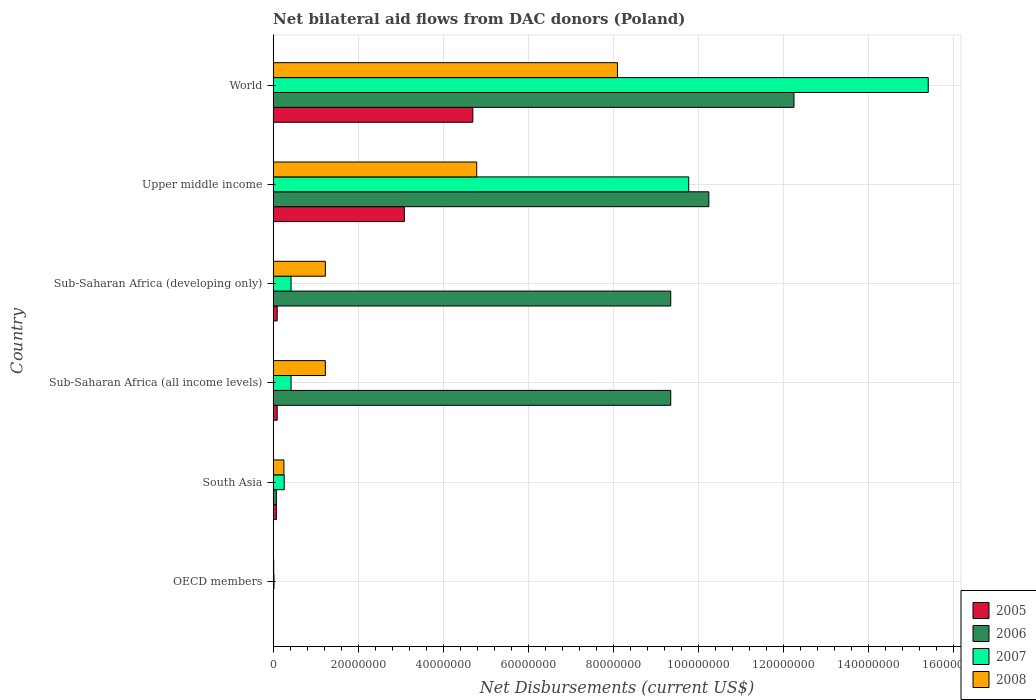Are the number of bars on each tick of the Y-axis equal?
Keep it short and to the point. Yes. What is the label of the 2nd group of bars from the top?
Give a very brief answer. Upper middle income. In how many cases, is the number of bars for a given country not equal to the number of legend labels?
Give a very brief answer. 0. What is the net bilateral aid flows in 2008 in Sub-Saharan Africa (all income levels)?
Provide a succinct answer. 1.23e+07. Across all countries, what is the maximum net bilateral aid flows in 2005?
Make the answer very short. 4.70e+07. What is the total net bilateral aid flows in 2005 in the graph?
Your answer should be compact. 8.06e+07. What is the difference between the net bilateral aid flows in 2005 in Sub-Saharan Africa (all income levels) and that in World?
Give a very brief answer. -4.60e+07. What is the difference between the net bilateral aid flows in 2006 in Sub-Saharan Africa (developing only) and the net bilateral aid flows in 2008 in Upper middle income?
Provide a short and direct response. 4.56e+07. What is the average net bilateral aid flows in 2005 per country?
Your response must be concise. 1.34e+07. What is the difference between the net bilateral aid flows in 2006 and net bilateral aid flows in 2007 in Sub-Saharan Africa (developing only)?
Keep it short and to the point. 8.93e+07. What is the ratio of the net bilateral aid flows in 2007 in OECD members to that in Upper middle income?
Offer a very short reply. 0. What is the difference between the highest and the second highest net bilateral aid flows in 2006?
Make the answer very short. 2.00e+07. What is the difference between the highest and the lowest net bilateral aid flows in 2005?
Offer a terse response. 4.69e+07. Is the sum of the net bilateral aid flows in 2006 in Sub-Saharan Africa (all income levels) and World greater than the maximum net bilateral aid flows in 2008 across all countries?
Your answer should be compact. Yes. Is it the case that in every country, the sum of the net bilateral aid flows in 2007 and net bilateral aid flows in 2008 is greater than the sum of net bilateral aid flows in 2006 and net bilateral aid flows in 2005?
Offer a terse response. No. What does the 4th bar from the top in Sub-Saharan Africa (all income levels) represents?
Your response must be concise. 2005. Is it the case that in every country, the sum of the net bilateral aid flows in 2006 and net bilateral aid flows in 2008 is greater than the net bilateral aid flows in 2007?
Your response must be concise. No. How many bars are there?
Provide a short and direct response. 24. Are all the bars in the graph horizontal?
Your answer should be compact. Yes. Does the graph contain any zero values?
Give a very brief answer. No. Does the graph contain grids?
Keep it short and to the point. Yes. How many legend labels are there?
Provide a short and direct response. 4. How are the legend labels stacked?
Your answer should be compact. Vertical. What is the title of the graph?
Your response must be concise. Net bilateral aid flows from DAC donors (Poland). Does "2005" appear as one of the legend labels in the graph?
Your response must be concise. Yes. What is the label or title of the X-axis?
Ensure brevity in your answer.  Net Disbursements (current US$). What is the Net Disbursements (current US$) of 2005 in OECD members?
Ensure brevity in your answer.  5.00e+04. What is the Net Disbursements (current US$) in 2006 in OECD members?
Offer a terse response. 3.00e+04. What is the Net Disbursements (current US$) in 2008 in OECD members?
Ensure brevity in your answer.  1.40e+05. What is the Net Disbursements (current US$) of 2005 in South Asia?
Your answer should be very brief. 7.70e+05. What is the Net Disbursements (current US$) of 2006 in South Asia?
Offer a very short reply. 7.70e+05. What is the Net Disbursements (current US$) of 2007 in South Asia?
Give a very brief answer. 2.61e+06. What is the Net Disbursements (current US$) of 2008 in South Asia?
Ensure brevity in your answer.  2.54e+06. What is the Net Disbursements (current US$) in 2005 in Sub-Saharan Africa (all income levels)?
Provide a succinct answer. 9.60e+05. What is the Net Disbursements (current US$) of 2006 in Sub-Saharan Africa (all income levels)?
Provide a short and direct response. 9.35e+07. What is the Net Disbursements (current US$) of 2007 in Sub-Saharan Africa (all income levels)?
Your answer should be compact. 4.22e+06. What is the Net Disbursements (current US$) in 2008 in Sub-Saharan Africa (all income levels)?
Give a very brief answer. 1.23e+07. What is the Net Disbursements (current US$) of 2005 in Sub-Saharan Africa (developing only)?
Keep it short and to the point. 9.60e+05. What is the Net Disbursements (current US$) in 2006 in Sub-Saharan Africa (developing only)?
Provide a succinct answer. 9.35e+07. What is the Net Disbursements (current US$) of 2007 in Sub-Saharan Africa (developing only)?
Make the answer very short. 4.22e+06. What is the Net Disbursements (current US$) in 2008 in Sub-Saharan Africa (developing only)?
Keep it short and to the point. 1.23e+07. What is the Net Disbursements (current US$) of 2005 in Upper middle income?
Your response must be concise. 3.09e+07. What is the Net Disbursements (current US$) in 2006 in Upper middle income?
Ensure brevity in your answer.  1.02e+08. What is the Net Disbursements (current US$) of 2007 in Upper middle income?
Your response must be concise. 9.78e+07. What is the Net Disbursements (current US$) of 2008 in Upper middle income?
Offer a very short reply. 4.79e+07. What is the Net Disbursements (current US$) in 2005 in World?
Provide a short and direct response. 4.70e+07. What is the Net Disbursements (current US$) in 2006 in World?
Offer a very short reply. 1.23e+08. What is the Net Disbursements (current US$) of 2007 in World?
Your answer should be compact. 1.54e+08. What is the Net Disbursements (current US$) in 2008 in World?
Offer a terse response. 8.10e+07. Across all countries, what is the maximum Net Disbursements (current US$) in 2005?
Your answer should be very brief. 4.70e+07. Across all countries, what is the maximum Net Disbursements (current US$) in 2006?
Offer a terse response. 1.23e+08. Across all countries, what is the maximum Net Disbursements (current US$) in 2007?
Give a very brief answer. 1.54e+08. Across all countries, what is the maximum Net Disbursements (current US$) in 2008?
Your response must be concise. 8.10e+07. Across all countries, what is the minimum Net Disbursements (current US$) of 2005?
Offer a terse response. 5.00e+04. Across all countries, what is the minimum Net Disbursements (current US$) of 2006?
Provide a short and direct response. 3.00e+04. Across all countries, what is the minimum Net Disbursements (current US$) of 2007?
Give a very brief answer. 2.10e+05. Across all countries, what is the minimum Net Disbursements (current US$) in 2008?
Ensure brevity in your answer.  1.40e+05. What is the total Net Disbursements (current US$) in 2005 in the graph?
Offer a terse response. 8.06e+07. What is the total Net Disbursements (current US$) in 2006 in the graph?
Offer a terse response. 4.13e+08. What is the total Net Disbursements (current US$) in 2007 in the graph?
Your answer should be very brief. 2.63e+08. What is the total Net Disbursements (current US$) in 2008 in the graph?
Ensure brevity in your answer.  1.56e+08. What is the difference between the Net Disbursements (current US$) in 2005 in OECD members and that in South Asia?
Offer a very short reply. -7.20e+05. What is the difference between the Net Disbursements (current US$) of 2006 in OECD members and that in South Asia?
Make the answer very short. -7.40e+05. What is the difference between the Net Disbursements (current US$) in 2007 in OECD members and that in South Asia?
Give a very brief answer. -2.40e+06. What is the difference between the Net Disbursements (current US$) in 2008 in OECD members and that in South Asia?
Provide a short and direct response. -2.40e+06. What is the difference between the Net Disbursements (current US$) of 2005 in OECD members and that in Sub-Saharan Africa (all income levels)?
Make the answer very short. -9.10e+05. What is the difference between the Net Disbursements (current US$) in 2006 in OECD members and that in Sub-Saharan Africa (all income levels)?
Make the answer very short. -9.35e+07. What is the difference between the Net Disbursements (current US$) of 2007 in OECD members and that in Sub-Saharan Africa (all income levels)?
Keep it short and to the point. -4.01e+06. What is the difference between the Net Disbursements (current US$) of 2008 in OECD members and that in Sub-Saharan Africa (all income levels)?
Offer a very short reply. -1.22e+07. What is the difference between the Net Disbursements (current US$) in 2005 in OECD members and that in Sub-Saharan Africa (developing only)?
Give a very brief answer. -9.10e+05. What is the difference between the Net Disbursements (current US$) in 2006 in OECD members and that in Sub-Saharan Africa (developing only)?
Make the answer very short. -9.35e+07. What is the difference between the Net Disbursements (current US$) of 2007 in OECD members and that in Sub-Saharan Africa (developing only)?
Provide a succinct answer. -4.01e+06. What is the difference between the Net Disbursements (current US$) in 2008 in OECD members and that in Sub-Saharan Africa (developing only)?
Give a very brief answer. -1.22e+07. What is the difference between the Net Disbursements (current US$) of 2005 in OECD members and that in Upper middle income?
Your response must be concise. -3.08e+07. What is the difference between the Net Disbursements (current US$) in 2006 in OECD members and that in Upper middle income?
Offer a terse response. -1.02e+08. What is the difference between the Net Disbursements (current US$) in 2007 in OECD members and that in Upper middle income?
Your response must be concise. -9.76e+07. What is the difference between the Net Disbursements (current US$) of 2008 in OECD members and that in Upper middle income?
Keep it short and to the point. -4.78e+07. What is the difference between the Net Disbursements (current US$) of 2005 in OECD members and that in World?
Ensure brevity in your answer.  -4.69e+07. What is the difference between the Net Disbursements (current US$) in 2006 in OECD members and that in World?
Keep it short and to the point. -1.22e+08. What is the difference between the Net Disbursements (current US$) in 2007 in OECD members and that in World?
Your answer should be compact. -1.54e+08. What is the difference between the Net Disbursements (current US$) of 2008 in OECD members and that in World?
Ensure brevity in your answer.  -8.09e+07. What is the difference between the Net Disbursements (current US$) of 2006 in South Asia and that in Sub-Saharan Africa (all income levels)?
Your answer should be very brief. -9.28e+07. What is the difference between the Net Disbursements (current US$) of 2007 in South Asia and that in Sub-Saharan Africa (all income levels)?
Your answer should be very brief. -1.61e+06. What is the difference between the Net Disbursements (current US$) of 2008 in South Asia and that in Sub-Saharan Africa (all income levels)?
Give a very brief answer. -9.75e+06. What is the difference between the Net Disbursements (current US$) of 2006 in South Asia and that in Sub-Saharan Africa (developing only)?
Your answer should be compact. -9.28e+07. What is the difference between the Net Disbursements (current US$) in 2007 in South Asia and that in Sub-Saharan Africa (developing only)?
Ensure brevity in your answer.  -1.61e+06. What is the difference between the Net Disbursements (current US$) of 2008 in South Asia and that in Sub-Saharan Africa (developing only)?
Offer a terse response. -9.75e+06. What is the difference between the Net Disbursements (current US$) in 2005 in South Asia and that in Upper middle income?
Provide a succinct answer. -3.01e+07. What is the difference between the Net Disbursements (current US$) in 2006 in South Asia and that in Upper middle income?
Keep it short and to the point. -1.02e+08. What is the difference between the Net Disbursements (current US$) of 2007 in South Asia and that in Upper middle income?
Your answer should be very brief. -9.52e+07. What is the difference between the Net Disbursements (current US$) in 2008 in South Asia and that in Upper middle income?
Ensure brevity in your answer.  -4.54e+07. What is the difference between the Net Disbursements (current US$) in 2005 in South Asia and that in World?
Provide a succinct answer. -4.62e+07. What is the difference between the Net Disbursements (current US$) of 2006 in South Asia and that in World?
Ensure brevity in your answer.  -1.22e+08. What is the difference between the Net Disbursements (current US$) in 2007 in South Asia and that in World?
Offer a very short reply. -1.52e+08. What is the difference between the Net Disbursements (current US$) in 2008 in South Asia and that in World?
Provide a succinct answer. -7.85e+07. What is the difference between the Net Disbursements (current US$) in 2006 in Sub-Saharan Africa (all income levels) and that in Sub-Saharan Africa (developing only)?
Offer a very short reply. 0. What is the difference between the Net Disbursements (current US$) in 2005 in Sub-Saharan Africa (all income levels) and that in Upper middle income?
Keep it short and to the point. -2.99e+07. What is the difference between the Net Disbursements (current US$) in 2006 in Sub-Saharan Africa (all income levels) and that in Upper middle income?
Your answer should be compact. -8.96e+06. What is the difference between the Net Disbursements (current US$) in 2007 in Sub-Saharan Africa (all income levels) and that in Upper middle income?
Offer a terse response. -9.36e+07. What is the difference between the Net Disbursements (current US$) of 2008 in Sub-Saharan Africa (all income levels) and that in Upper middle income?
Offer a very short reply. -3.56e+07. What is the difference between the Net Disbursements (current US$) in 2005 in Sub-Saharan Africa (all income levels) and that in World?
Give a very brief answer. -4.60e+07. What is the difference between the Net Disbursements (current US$) in 2006 in Sub-Saharan Africa (all income levels) and that in World?
Your answer should be very brief. -2.90e+07. What is the difference between the Net Disbursements (current US$) of 2007 in Sub-Saharan Africa (all income levels) and that in World?
Make the answer very short. -1.50e+08. What is the difference between the Net Disbursements (current US$) of 2008 in Sub-Saharan Africa (all income levels) and that in World?
Make the answer very short. -6.87e+07. What is the difference between the Net Disbursements (current US$) of 2005 in Sub-Saharan Africa (developing only) and that in Upper middle income?
Give a very brief answer. -2.99e+07. What is the difference between the Net Disbursements (current US$) of 2006 in Sub-Saharan Africa (developing only) and that in Upper middle income?
Provide a short and direct response. -8.96e+06. What is the difference between the Net Disbursements (current US$) of 2007 in Sub-Saharan Africa (developing only) and that in Upper middle income?
Keep it short and to the point. -9.36e+07. What is the difference between the Net Disbursements (current US$) of 2008 in Sub-Saharan Africa (developing only) and that in Upper middle income?
Ensure brevity in your answer.  -3.56e+07. What is the difference between the Net Disbursements (current US$) in 2005 in Sub-Saharan Africa (developing only) and that in World?
Your response must be concise. -4.60e+07. What is the difference between the Net Disbursements (current US$) in 2006 in Sub-Saharan Africa (developing only) and that in World?
Provide a short and direct response. -2.90e+07. What is the difference between the Net Disbursements (current US$) in 2007 in Sub-Saharan Africa (developing only) and that in World?
Provide a succinct answer. -1.50e+08. What is the difference between the Net Disbursements (current US$) of 2008 in Sub-Saharan Africa (developing only) and that in World?
Offer a very short reply. -6.87e+07. What is the difference between the Net Disbursements (current US$) in 2005 in Upper middle income and that in World?
Your answer should be very brief. -1.61e+07. What is the difference between the Net Disbursements (current US$) in 2006 in Upper middle income and that in World?
Provide a succinct answer. -2.00e+07. What is the difference between the Net Disbursements (current US$) of 2007 in Upper middle income and that in World?
Provide a short and direct response. -5.63e+07. What is the difference between the Net Disbursements (current US$) of 2008 in Upper middle income and that in World?
Provide a short and direct response. -3.31e+07. What is the difference between the Net Disbursements (current US$) in 2005 in OECD members and the Net Disbursements (current US$) in 2006 in South Asia?
Offer a very short reply. -7.20e+05. What is the difference between the Net Disbursements (current US$) in 2005 in OECD members and the Net Disbursements (current US$) in 2007 in South Asia?
Provide a short and direct response. -2.56e+06. What is the difference between the Net Disbursements (current US$) of 2005 in OECD members and the Net Disbursements (current US$) of 2008 in South Asia?
Provide a short and direct response. -2.49e+06. What is the difference between the Net Disbursements (current US$) of 2006 in OECD members and the Net Disbursements (current US$) of 2007 in South Asia?
Offer a terse response. -2.58e+06. What is the difference between the Net Disbursements (current US$) in 2006 in OECD members and the Net Disbursements (current US$) in 2008 in South Asia?
Give a very brief answer. -2.51e+06. What is the difference between the Net Disbursements (current US$) in 2007 in OECD members and the Net Disbursements (current US$) in 2008 in South Asia?
Your answer should be compact. -2.33e+06. What is the difference between the Net Disbursements (current US$) of 2005 in OECD members and the Net Disbursements (current US$) of 2006 in Sub-Saharan Africa (all income levels)?
Your response must be concise. -9.35e+07. What is the difference between the Net Disbursements (current US$) of 2005 in OECD members and the Net Disbursements (current US$) of 2007 in Sub-Saharan Africa (all income levels)?
Keep it short and to the point. -4.17e+06. What is the difference between the Net Disbursements (current US$) in 2005 in OECD members and the Net Disbursements (current US$) in 2008 in Sub-Saharan Africa (all income levels)?
Give a very brief answer. -1.22e+07. What is the difference between the Net Disbursements (current US$) of 2006 in OECD members and the Net Disbursements (current US$) of 2007 in Sub-Saharan Africa (all income levels)?
Your response must be concise. -4.19e+06. What is the difference between the Net Disbursements (current US$) of 2006 in OECD members and the Net Disbursements (current US$) of 2008 in Sub-Saharan Africa (all income levels)?
Provide a short and direct response. -1.23e+07. What is the difference between the Net Disbursements (current US$) in 2007 in OECD members and the Net Disbursements (current US$) in 2008 in Sub-Saharan Africa (all income levels)?
Your answer should be very brief. -1.21e+07. What is the difference between the Net Disbursements (current US$) in 2005 in OECD members and the Net Disbursements (current US$) in 2006 in Sub-Saharan Africa (developing only)?
Make the answer very short. -9.35e+07. What is the difference between the Net Disbursements (current US$) of 2005 in OECD members and the Net Disbursements (current US$) of 2007 in Sub-Saharan Africa (developing only)?
Your answer should be very brief. -4.17e+06. What is the difference between the Net Disbursements (current US$) of 2005 in OECD members and the Net Disbursements (current US$) of 2008 in Sub-Saharan Africa (developing only)?
Offer a terse response. -1.22e+07. What is the difference between the Net Disbursements (current US$) in 2006 in OECD members and the Net Disbursements (current US$) in 2007 in Sub-Saharan Africa (developing only)?
Offer a terse response. -4.19e+06. What is the difference between the Net Disbursements (current US$) of 2006 in OECD members and the Net Disbursements (current US$) of 2008 in Sub-Saharan Africa (developing only)?
Give a very brief answer. -1.23e+07. What is the difference between the Net Disbursements (current US$) in 2007 in OECD members and the Net Disbursements (current US$) in 2008 in Sub-Saharan Africa (developing only)?
Give a very brief answer. -1.21e+07. What is the difference between the Net Disbursements (current US$) of 2005 in OECD members and the Net Disbursements (current US$) of 2006 in Upper middle income?
Keep it short and to the point. -1.02e+08. What is the difference between the Net Disbursements (current US$) in 2005 in OECD members and the Net Disbursements (current US$) in 2007 in Upper middle income?
Give a very brief answer. -9.77e+07. What is the difference between the Net Disbursements (current US$) in 2005 in OECD members and the Net Disbursements (current US$) in 2008 in Upper middle income?
Your response must be concise. -4.78e+07. What is the difference between the Net Disbursements (current US$) of 2006 in OECD members and the Net Disbursements (current US$) of 2007 in Upper middle income?
Provide a succinct answer. -9.77e+07. What is the difference between the Net Disbursements (current US$) in 2006 in OECD members and the Net Disbursements (current US$) in 2008 in Upper middle income?
Provide a short and direct response. -4.79e+07. What is the difference between the Net Disbursements (current US$) in 2007 in OECD members and the Net Disbursements (current US$) in 2008 in Upper middle income?
Give a very brief answer. -4.77e+07. What is the difference between the Net Disbursements (current US$) in 2005 in OECD members and the Net Disbursements (current US$) in 2006 in World?
Your answer should be compact. -1.22e+08. What is the difference between the Net Disbursements (current US$) in 2005 in OECD members and the Net Disbursements (current US$) in 2007 in World?
Your answer should be compact. -1.54e+08. What is the difference between the Net Disbursements (current US$) of 2005 in OECD members and the Net Disbursements (current US$) of 2008 in World?
Your answer should be compact. -8.10e+07. What is the difference between the Net Disbursements (current US$) of 2006 in OECD members and the Net Disbursements (current US$) of 2007 in World?
Offer a terse response. -1.54e+08. What is the difference between the Net Disbursements (current US$) of 2006 in OECD members and the Net Disbursements (current US$) of 2008 in World?
Keep it short and to the point. -8.10e+07. What is the difference between the Net Disbursements (current US$) of 2007 in OECD members and the Net Disbursements (current US$) of 2008 in World?
Ensure brevity in your answer.  -8.08e+07. What is the difference between the Net Disbursements (current US$) in 2005 in South Asia and the Net Disbursements (current US$) in 2006 in Sub-Saharan Africa (all income levels)?
Give a very brief answer. -9.28e+07. What is the difference between the Net Disbursements (current US$) in 2005 in South Asia and the Net Disbursements (current US$) in 2007 in Sub-Saharan Africa (all income levels)?
Give a very brief answer. -3.45e+06. What is the difference between the Net Disbursements (current US$) in 2005 in South Asia and the Net Disbursements (current US$) in 2008 in Sub-Saharan Africa (all income levels)?
Your answer should be very brief. -1.15e+07. What is the difference between the Net Disbursements (current US$) in 2006 in South Asia and the Net Disbursements (current US$) in 2007 in Sub-Saharan Africa (all income levels)?
Offer a terse response. -3.45e+06. What is the difference between the Net Disbursements (current US$) in 2006 in South Asia and the Net Disbursements (current US$) in 2008 in Sub-Saharan Africa (all income levels)?
Make the answer very short. -1.15e+07. What is the difference between the Net Disbursements (current US$) in 2007 in South Asia and the Net Disbursements (current US$) in 2008 in Sub-Saharan Africa (all income levels)?
Your response must be concise. -9.68e+06. What is the difference between the Net Disbursements (current US$) of 2005 in South Asia and the Net Disbursements (current US$) of 2006 in Sub-Saharan Africa (developing only)?
Keep it short and to the point. -9.28e+07. What is the difference between the Net Disbursements (current US$) of 2005 in South Asia and the Net Disbursements (current US$) of 2007 in Sub-Saharan Africa (developing only)?
Your answer should be compact. -3.45e+06. What is the difference between the Net Disbursements (current US$) of 2005 in South Asia and the Net Disbursements (current US$) of 2008 in Sub-Saharan Africa (developing only)?
Make the answer very short. -1.15e+07. What is the difference between the Net Disbursements (current US$) of 2006 in South Asia and the Net Disbursements (current US$) of 2007 in Sub-Saharan Africa (developing only)?
Offer a terse response. -3.45e+06. What is the difference between the Net Disbursements (current US$) in 2006 in South Asia and the Net Disbursements (current US$) in 2008 in Sub-Saharan Africa (developing only)?
Your answer should be compact. -1.15e+07. What is the difference between the Net Disbursements (current US$) of 2007 in South Asia and the Net Disbursements (current US$) of 2008 in Sub-Saharan Africa (developing only)?
Ensure brevity in your answer.  -9.68e+06. What is the difference between the Net Disbursements (current US$) of 2005 in South Asia and the Net Disbursements (current US$) of 2006 in Upper middle income?
Your response must be concise. -1.02e+08. What is the difference between the Net Disbursements (current US$) of 2005 in South Asia and the Net Disbursements (current US$) of 2007 in Upper middle income?
Offer a very short reply. -9.70e+07. What is the difference between the Net Disbursements (current US$) in 2005 in South Asia and the Net Disbursements (current US$) in 2008 in Upper middle income?
Provide a short and direct response. -4.71e+07. What is the difference between the Net Disbursements (current US$) in 2006 in South Asia and the Net Disbursements (current US$) in 2007 in Upper middle income?
Your answer should be compact. -9.70e+07. What is the difference between the Net Disbursements (current US$) in 2006 in South Asia and the Net Disbursements (current US$) in 2008 in Upper middle income?
Offer a very short reply. -4.71e+07. What is the difference between the Net Disbursements (current US$) in 2007 in South Asia and the Net Disbursements (current US$) in 2008 in Upper middle income?
Provide a short and direct response. -4.53e+07. What is the difference between the Net Disbursements (current US$) in 2005 in South Asia and the Net Disbursements (current US$) in 2006 in World?
Keep it short and to the point. -1.22e+08. What is the difference between the Net Disbursements (current US$) in 2005 in South Asia and the Net Disbursements (current US$) in 2007 in World?
Your response must be concise. -1.53e+08. What is the difference between the Net Disbursements (current US$) of 2005 in South Asia and the Net Disbursements (current US$) of 2008 in World?
Offer a terse response. -8.02e+07. What is the difference between the Net Disbursements (current US$) of 2006 in South Asia and the Net Disbursements (current US$) of 2007 in World?
Your answer should be compact. -1.53e+08. What is the difference between the Net Disbursements (current US$) of 2006 in South Asia and the Net Disbursements (current US$) of 2008 in World?
Offer a very short reply. -8.02e+07. What is the difference between the Net Disbursements (current US$) in 2007 in South Asia and the Net Disbursements (current US$) in 2008 in World?
Provide a short and direct response. -7.84e+07. What is the difference between the Net Disbursements (current US$) of 2005 in Sub-Saharan Africa (all income levels) and the Net Disbursements (current US$) of 2006 in Sub-Saharan Africa (developing only)?
Provide a succinct answer. -9.26e+07. What is the difference between the Net Disbursements (current US$) in 2005 in Sub-Saharan Africa (all income levels) and the Net Disbursements (current US$) in 2007 in Sub-Saharan Africa (developing only)?
Offer a very short reply. -3.26e+06. What is the difference between the Net Disbursements (current US$) in 2005 in Sub-Saharan Africa (all income levels) and the Net Disbursements (current US$) in 2008 in Sub-Saharan Africa (developing only)?
Your answer should be compact. -1.13e+07. What is the difference between the Net Disbursements (current US$) of 2006 in Sub-Saharan Africa (all income levels) and the Net Disbursements (current US$) of 2007 in Sub-Saharan Africa (developing only)?
Provide a succinct answer. 8.93e+07. What is the difference between the Net Disbursements (current US$) of 2006 in Sub-Saharan Africa (all income levels) and the Net Disbursements (current US$) of 2008 in Sub-Saharan Africa (developing only)?
Keep it short and to the point. 8.12e+07. What is the difference between the Net Disbursements (current US$) in 2007 in Sub-Saharan Africa (all income levels) and the Net Disbursements (current US$) in 2008 in Sub-Saharan Africa (developing only)?
Ensure brevity in your answer.  -8.07e+06. What is the difference between the Net Disbursements (current US$) in 2005 in Sub-Saharan Africa (all income levels) and the Net Disbursements (current US$) in 2006 in Upper middle income?
Provide a succinct answer. -1.02e+08. What is the difference between the Net Disbursements (current US$) of 2005 in Sub-Saharan Africa (all income levels) and the Net Disbursements (current US$) of 2007 in Upper middle income?
Your answer should be very brief. -9.68e+07. What is the difference between the Net Disbursements (current US$) in 2005 in Sub-Saharan Africa (all income levels) and the Net Disbursements (current US$) in 2008 in Upper middle income?
Make the answer very short. -4.69e+07. What is the difference between the Net Disbursements (current US$) in 2006 in Sub-Saharan Africa (all income levels) and the Net Disbursements (current US$) in 2007 in Upper middle income?
Your response must be concise. -4.23e+06. What is the difference between the Net Disbursements (current US$) in 2006 in Sub-Saharan Africa (all income levels) and the Net Disbursements (current US$) in 2008 in Upper middle income?
Offer a terse response. 4.56e+07. What is the difference between the Net Disbursements (current US$) of 2007 in Sub-Saharan Africa (all income levels) and the Net Disbursements (current US$) of 2008 in Upper middle income?
Make the answer very short. -4.37e+07. What is the difference between the Net Disbursements (current US$) of 2005 in Sub-Saharan Africa (all income levels) and the Net Disbursements (current US$) of 2006 in World?
Provide a succinct answer. -1.22e+08. What is the difference between the Net Disbursements (current US$) of 2005 in Sub-Saharan Africa (all income levels) and the Net Disbursements (current US$) of 2007 in World?
Your response must be concise. -1.53e+08. What is the difference between the Net Disbursements (current US$) of 2005 in Sub-Saharan Africa (all income levels) and the Net Disbursements (current US$) of 2008 in World?
Your answer should be compact. -8.00e+07. What is the difference between the Net Disbursements (current US$) in 2006 in Sub-Saharan Africa (all income levels) and the Net Disbursements (current US$) in 2007 in World?
Provide a succinct answer. -6.06e+07. What is the difference between the Net Disbursements (current US$) of 2006 in Sub-Saharan Africa (all income levels) and the Net Disbursements (current US$) of 2008 in World?
Offer a terse response. 1.25e+07. What is the difference between the Net Disbursements (current US$) in 2007 in Sub-Saharan Africa (all income levels) and the Net Disbursements (current US$) in 2008 in World?
Provide a short and direct response. -7.68e+07. What is the difference between the Net Disbursements (current US$) in 2005 in Sub-Saharan Africa (developing only) and the Net Disbursements (current US$) in 2006 in Upper middle income?
Your answer should be compact. -1.02e+08. What is the difference between the Net Disbursements (current US$) of 2005 in Sub-Saharan Africa (developing only) and the Net Disbursements (current US$) of 2007 in Upper middle income?
Keep it short and to the point. -9.68e+07. What is the difference between the Net Disbursements (current US$) of 2005 in Sub-Saharan Africa (developing only) and the Net Disbursements (current US$) of 2008 in Upper middle income?
Give a very brief answer. -4.69e+07. What is the difference between the Net Disbursements (current US$) in 2006 in Sub-Saharan Africa (developing only) and the Net Disbursements (current US$) in 2007 in Upper middle income?
Make the answer very short. -4.23e+06. What is the difference between the Net Disbursements (current US$) of 2006 in Sub-Saharan Africa (developing only) and the Net Disbursements (current US$) of 2008 in Upper middle income?
Make the answer very short. 4.56e+07. What is the difference between the Net Disbursements (current US$) of 2007 in Sub-Saharan Africa (developing only) and the Net Disbursements (current US$) of 2008 in Upper middle income?
Ensure brevity in your answer.  -4.37e+07. What is the difference between the Net Disbursements (current US$) in 2005 in Sub-Saharan Africa (developing only) and the Net Disbursements (current US$) in 2006 in World?
Provide a succinct answer. -1.22e+08. What is the difference between the Net Disbursements (current US$) in 2005 in Sub-Saharan Africa (developing only) and the Net Disbursements (current US$) in 2007 in World?
Provide a succinct answer. -1.53e+08. What is the difference between the Net Disbursements (current US$) in 2005 in Sub-Saharan Africa (developing only) and the Net Disbursements (current US$) in 2008 in World?
Offer a very short reply. -8.00e+07. What is the difference between the Net Disbursements (current US$) in 2006 in Sub-Saharan Africa (developing only) and the Net Disbursements (current US$) in 2007 in World?
Your answer should be very brief. -6.06e+07. What is the difference between the Net Disbursements (current US$) of 2006 in Sub-Saharan Africa (developing only) and the Net Disbursements (current US$) of 2008 in World?
Your answer should be compact. 1.25e+07. What is the difference between the Net Disbursements (current US$) of 2007 in Sub-Saharan Africa (developing only) and the Net Disbursements (current US$) of 2008 in World?
Keep it short and to the point. -7.68e+07. What is the difference between the Net Disbursements (current US$) of 2005 in Upper middle income and the Net Disbursements (current US$) of 2006 in World?
Your response must be concise. -9.17e+07. What is the difference between the Net Disbursements (current US$) of 2005 in Upper middle income and the Net Disbursements (current US$) of 2007 in World?
Offer a very short reply. -1.23e+08. What is the difference between the Net Disbursements (current US$) in 2005 in Upper middle income and the Net Disbursements (current US$) in 2008 in World?
Your answer should be very brief. -5.01e+07. What is the difference between the Net Disbursements (current US$) in 2006 in Upper middle income and the Net Disbursements (current US$) in 2007 in World?
Offer a very short reply. -5.16e+07. What is the difference between the Net Disbursements (current US$) in 2006 in Upper middle income and the Net Disbursements (current US$) in 2008 in World?
Offer a very short reply. 2.15e+07. What is the difference between the Net Disbursements (current US$) in 2007 in Upper middle income and the Net Disbursements (current US$) in 2008 in World?
Keep it short and to the point. 1.68e+07. What is the average Net Disbursements (current US$) of 2005 per country?
Offer a very short reply. 1.34e+07. What is the average Net Disbursements (current US$) of 2006 per country?
Give a very brief answer. 6.88e+07. What is the average Net Disbursements (current US$) in 2007 per country?
Offer a terse response. 4.39e+07. What is the average Net Disbursements (current US$) in 2008 per country?
Make the answer very short. 2.60e+07. What is the difference between the Net Disbursements (current US$) in 2005 and Net Disbursements (current US$) in 2008 in OECD members?
Your response must be concise. -9.00e+04. What is the difference between the Net Disbursements (current US$) in 2006 and Net Disbursements (current US$) in 2007 in OECD members?
Offer a terse response. -1.80e+05. What is the difference between the Net Disbursements (current US$) of 2006 and Net Disbursements (current US$) of 2008 in OECD members?
Give a very brief answer. -1.10e+05. What is the difference between the Net Disbursements (current US$) of 2005 and Net Disbursements (current US$) of 2006 in South Asia?
Provide a short and direct response. 0. What is the difference between the Net Disbursements (current US$) of 2005 and Net Disbursements (current US$) of 2007 in South Asia?
Your answer should be very brief. -1.84e+06. What is the difference between the Net Disbursements (current US$) of 2005 and Net Disbursements (current US$) of 2008 in South Asia?
Your answer should be very brief. -1.77e+06. What is the difference between the Net Disbursements (current US$) in 2006 and Net Disbursements (current US$) in 2007 in South Asia?
Make the answer very short. -1.84e+06. What is the difference between the Net Disbursements (current US$) of 2006 and Net Disbursements (current US$) of 2008 in South Asia?
Offer a terse response. -1.77e+06. What is the difference between the Net Disbursements (current US$) in 2005 and Net Disbursements (current US$) in 2006 in Sub-Saharan Africa (all income levels)?
Your answer should be very brief. -9.26e+07. What is the difference between the Net Disbursements (current US$) of 2005 and Net Disbursements (current US$) of 2007 in Sub-Saharan Africa (all income levels)?
Offer a very short reply. -3.26e+06. What is the difference between the Net Disbursements (current US$) of 2005 and Net Disbursements (current US$) of 2008 in Sub-Saharan Africa (all income levels)?
Offer a terse response. -1.13e+07. What is the difference between the Net Disbursements (current US$) in 2006 and Net Disbursements (current US$) in 2007 in Sub-Saharan Africa (all income levels)?
Give a very brief answer. 8.93e+07. What is the difference between the Net Disbursements (current US$) of 2006 and Net Disbursements (current US$) of 2008 in Sub-Saharan Africa (all income levels)?
Provide a short and direct response. 8.12e+07. What is the difference between the Net Disbursements (current US$) of 2007 and Net Disbursements (current US$) of 2008 in Sub-Saharan Africa (all income levels)?
Provide a succinct answer. -8.07e+06. What is the difference between the Net Disbursements (current US$) of 2005 and Net Disbursements (current US$) of 2006 in Sub-Saharan Africa (developing only)?
Provide a succinct answer. -9.26e+07. What is the difference between the Net Disbursements (current US$) of 2005 and Net Disbursements (current US$) of 2007 in Sub-Saharan Africa (developing only)?
Your answer should be very brief. -3.26e+06. What is the difference between the Net Disbursements (current US$) of 2005 and Net Disbursements (current US$) of 2008 in Sub-Saharan Africa (developing only)?
Ensure brevity in your answer.  -1.13e+07. What is the difference between the Net Disbursements (current US$) of 2006 and Net Disbursements (current US$) of 2007 in Sub-Saharan Africa (developing only)?
Give a very brief answer. 8.93e+07. What is the difference between the Net Disbursements (current US$) of 2006 and Net Disbursements (current US$) of 2008 in Sub-Saharan Africa (developing only)?
Your answer should be compact. 8.12e+07. What is the difference between the Net Disbursements (current US$) of 2007 and Net Disbursements (current US$) of 2008 in Sub-Saharan Africa (developing only)?
Your answer should be compact. -8.07e+06. What is the difference between the Net Disbursements (current US$) of 2005 and Net Disbursements (current US$) of 2006 in Upper middle income?
Make the answer very short. -7.16e+07. What is the difference between the Net Disbursements (current US$) of 2005 and Net Disbursements (current US$) of 2007 in Upper middle income?
Give a very brief answer. -6.69e+07. What is the difference between the Net Disbursements (current US$) in 2005 and Net Disbursements (current US$) in 2008 in Upper middle income?
Provide a succinct answer. -1.70e+07. What is the difference between the Net Disbursements (current US$) of 2006 and Net Disbursements (current US$) of 2007 in Upper middle income?
Your answer should be very brief. 4.73e+06. What is the difference between the Net Disbursements (current US$) in 2006 and Net Disbursements (current US$) in 2008 in Upper middle income?
Your answer should be compact. 5.46e+07. What is the difference between the Net Disbursements (current US$) in 2007 and Net Disbursements (current US$) in 2008 in Upper middle income?
Provide a short and direct response. 4.99e+07. What is the difference between the Net Disbursements (current US$) of 2005 and Net Disbursements (current US$) of 2006 in World?
Your answer should be very brief. -7.56e+07. What is the difference between the Net Disbursements (current US$) of 2005 and Net Disbursements (current US$) of 2007 in World?
Your answer should be very brief. -1.07e+08. What is the difference between the Net Disbursements (current US$) of 2005 and Net Disbursements (current US$) of 2008 in World?
Give a very brief answer. -3.40e+07. What is the difference between the Net Disbursements (current US$) of 2006 and Net Disbursements (current US$) of 2007 in World?
Your answer should be very brief. -3.16e+07. What is the difference between the Net Disbursements (current US$) of 2006 and Net Disbursements (current US$) of 2008 in World?
Provide a short and direct response. 4.15e+07. What is the difference between the Net Disbursements (current US$) in 2007 and Net Disbursements (current US$) in 2008 in World?
Your answer should be compact. 7.31e+07. What is the ratio of the Net Disbursements (current US$) of 2005 in OECD members to that in South Asia?
Provide a succinct answer. 0.06. What is the ratio of the Net Disbursements (current US$) in 2006 in OECD members to that in South Asia?
Your response must be concise. 0.04. What is the ratio of the Net Disbursements (current US$) in 2007 in OECD members to that in South Asia?
Keep it short and to the point. 0.08. What is the ratio of the Net Disbursements (current US$) in 2008 in OECD members to that in South Asia?
Give a very brief answer. 0.06. What is the ratio of the Net Disbursements (current US$) in 2005 in OECD members to that in Sub-Saharan Africa (all income levels)?
Your response must be concise. 0.05. What is the ratio of the Net Disbursements (current US$) of 2007 in OECD members to that in Sub-Saharan Africa (all income levels)?
Provide a short and direct response. 0.05. What is the ratio of the Net Disbursements (current US$) in 2008 in OECD members to that in Sub-Saharan Africa (all income levels)?
Keep it short and to the point. 0.01. What is the ratio of the Net Disbursements (current US$) of 2005 in OECD members to that in Sub-Saharan Africa (developing only)?
Make the answer very short. 0.05. What is the ratio of the Net Disbursements (current US$) in 2007 in OECD members to that in Sub-Saharan Africa (developing only)?
Provide a short and direct response. 0.05. What is the ratio of the Net Disbursements (current US$) in 2008 in OECD members to that in Sub-Saharan Africa (developing only)?
Make the answer very short. 0.01. What is the ratio of the Net Disbursements (current US$) in 2005 in OECD members to that in Upper middle income?
Keep it short and to the point. 0. What is the ratio of the Net Disbursements (current US$) of 2007 in OECD members to that in Upper middle income?
Give a very brief answer. 0. What is the ratio of the Net Disbursements (current US$) in 2008 in OECD members to that in Upper middle income?
Give a very brief answer. 0. What is the ratio of the Net Disbursements (current US$) in 2005 in OECD members to that in World?
Your answer should be very brief. 0. What is the ratio of the Net Disbursements (current US$) in 2006 in OECD members to that in World?
Offer a terse response. 0. What is the ratio of the Net Disbursements (current US$) in 2007 in OECD members to that in World?
Make the answer very short. 0. What is the ratio of the Net Disbursements (current US$) in 2008 in OECD members to that in World?
Your answer should be compact. 0. What is the ratio of the Net Disbursements (current US$) in 2005 in South Asia to that in Sub-Saharan Africa (all income levels)?
Make the answer very short. 0.8. What is the ratio of the Net Disbursements (current US$) in 2006 in South Asia to that in Sub-Saharan Africa (all income levels)?
Your response must be concise. 0.01. What is the ratio of the Net Disbursements (current US$) of 2007 in South Asia to that in Sub-Saharan Africa (all income levels)?
Offer a very short reply. 0.62. What is the ratio of the Net Disbursements (current US$) of 2008 in South Asia to that in Sub-Saharan Africa (all income levels)?
Provide a short and direct response. 0.21. What is the ratio of the Net Disbursements (current US$) in 2005 in South Asia to that in Sub-Saharan Africa (developing only)?
Ensure brevity in your answer.  0.8. What is the ratio of the Net Disbursements (current US$) in 2006 in South Asia to that in Sub-Saharan Africa (developing only)?
Provide a short and direct response. 0.01. What is the ratio of the Net Disbursements (current US$) of 2007 in South Asia to that in Sub-Saharan Africa (developing only)?
Provide a short and direct response. 0.62. What is the ratio of the Net Disbursements (current US$) in 2008 in South Asia to that in Sub-Saharan Africa (developing only)?
Your response must be concise. 0.21. What is the ratio of the Net Disbursements (current US$) in 2005 in South Asia to that in Upper middle income?
Your answer should be compact. 0.02. What is the ratio of the Net Disbursements (current US$) of 2006 in South Asia to that in Upper middle income?
Provide a short and direct response. 0.01. What is the ratio of the Net Disbursements (current US$) in 2007 in South Asia to that in Upper middle income?
Give a very brief answer. 0.03. What is the ratio of the Net Disbursements (current US$) in 2008 in South Asia to that in Upper middle income?
Give a very brief answer. 0.05. What is the ratio of the Net Disbursements (current US$) in 2005 in South Asia to that in World?
Provide a short and direct response. 0.02. What is the ratio of the Net Disbursements (current US$) of 2006 in South Asia to that in World?
Your answer should be compact. 0.01. What is the ratio of the Net Disbursements (current US$) in 2007 in South Asia to that in World?
Keep it short and to the point. 0.02. What is the ratio of the Net Disbursements (current US$) of 2008 in South Asia to that in World?
Make the answer very short. 0.03. What is the ratio of the Net Disbursements (current US$) of 2007 in Sub-Saharan Africa (all income levels) to that in Sub-Saharan Africa (developing only)?
Give a very brief answer. 1. What is the ratio of the Net Disbursements (current US$) in 2008 in Sub-Saharan Africa (all income levels) to that in Sub-Saharan Africa (developing only)?
Provide a short and direct response. 1. What is the ratio of the Net Disbursements (current US$) in 2005 in Sub-Saharan Africa (all income levels) to that in Upper middle income?
Offer a terse response. 0.03. What is the ratio of the Net Disbursements (current US$) in 2006 in Sub-Saharan Africa (all income levels) to that in Upper middle income?
Make the answer very short. 0.91. What is the ratio of the Net Disbursements (current US$) in 2007 in Sub-Saharan Africa (all income levels) to that in Upper middle income?
Your response must be concise. 0.04. What is the ratio of the Net Disbursements (current US$) in 2008 in Sub-Saharan Africa (all income levels) to that in Upper middle income?
Offer a terse response. 0.26. What is the ratio of the Net Disbursements (current US$) in 2005 in Sub-Saharan Africa (all income levels) to that in World?
Your answer should be compact. 0.02. What is the ratio of the Net Disbursements (current US$) of 2006 in Sub-Saharan Africa (all income levels) to that in World?
Your answer should be compact. 0.76. What is the ratio of the Net Disbursements (current US$) of 2007 in Sub-Saharan Africa (all income levels) to that in World?
Make the answer very short. 0.03. What is the ratio of the Net Disbursements (current US$) of 2008 in Sub-Saharan Africa (all income levels) to that in World?
Your answer should be compact. 0.15. What is the ratio of the Net Disbursements (current US$) of 2005 in Sub-Saharan Africa (developing only) to that in Upper middle income?
Provide a succinct answer. 0.03. What is the ratio of the Net Disbursements (current US$) of 2006 in Sub-Saharan Africa (developing only) to that in Upper middle income?
Give a very brief answer. 0.91. What is the ratio of the Net Disbursements (current US$) in 2007 in Sub-Saharan Africa (developing only) to that in Upper middle income?
Make the answer very short. 0.04. What is the ratio of the Net Disbursements (current US$) in 2008 in Sub-Saharan Africa (developing only) to that in Upper middle income?
Make the answer very short. 0.26. What is the ratio of the Net Disbursements (current US$) in 2005 in Sub-Saharan Africa (developing only) to that in World?
Your answer should be very brief. 0.02. What is the ratio of the Net Disbursements (current US$) of 2006 in Sub-Saharan Africa (developing only) to that in World?
Keep it short and to the point. 0.76. What is the ratio of the Net Disbursements (current US$) in 2007 in Sub-Saharan Africa (developing only) to that in World?
Offer a terse response. 0.03. What is the ratio of the Net Disbursements (current US$) in 2008 in Sub-Saharan Africa (developing only) to that in World?
Your response must be concise. 0.15. What is the ratio of the Net Disbursements (current US$) in 2005 in Upper middle income to that in World?
Provide a short and direct response. 0.66. What is the ratio of the Net Disbursements (current US$) in 2006 in Upper middle income to that in World?
Provide a short and direct response. 0.84. What is the ratio of the Net Disbursements (current US$) in 2007 in Upper middle income to that in World?
Give a very brief answer. 0.63. What is the ratio of the Net Disbursements (current US$) in 2008 in Upper middle income to that in World?
Keep it short and to the point. 0.59. What is the difference between the highest and the second highest Net Disbursements (current US$) of 2005?
Keep it short and to the point. 1.61e+07. What is the difference between the highest and the second highest Net Disbursements (current US$) of 2006?
Your answer should be compact. 2.00e+07. What is the difference between the highest and the second highest Net Disbursements (current US$) in 2007?
Make the answer very short. 5.63e+07. What is the difference between the highest and the second highest Net Disbursements (current US$) of 2008?
Your answer should be very brief. 3.31e+07. What is the difference between the highest and the lowest Net Disbursements (current US$) in 2005?
Ensure brevity in your answer.  4.69e+07. What is the difference between the highest and the lowest Net Disbursements (current US$) of 2006?
Your answer should be very brief. 1.22e+08. What is the difference between the highest and the lowest Net Disbursements (current US$) in 2007?
Provide a succinct answer. 1.54e+08. What is the difference between the highest and the lowest Net Disbursements (current US$) in 2008?
Provide a short and direct response. 8.09e+07. 